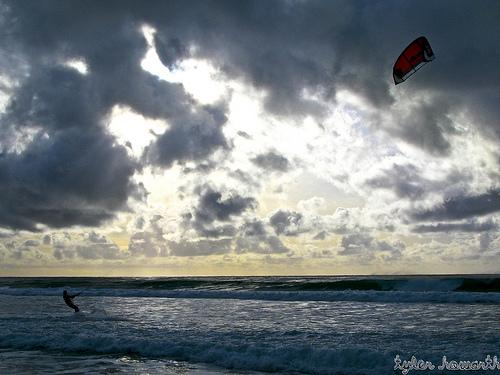Explain what kind of weather is depicted in the image and how it affects the overall atmosphere. The weather in the image showcases an overcast sky with a hidden sun trying to peek through the thickening clouds, lending to an air of intrigue and otherworldly beauty that meshes seamlessly with the calm waters and peaceful beach. How would you describe the water in the image to a person who cannot see the image? The waters in the image are calm and wavey, with various shades of blue, light reflecting from certain points, and the gentle waves rolling towards the shore, creating a serene and inviting scene. Choose three objects from the image and comment about their appearance. The fascinating black clouds contrast beautifully against the white backdrop of the sky, while an orange and red parasail adds a touch of color to the overall scene. The shallowest water nearest the beach showcases a serene atmosphere, inviting one to step in. Create a poetic description of the scene depicted in the image. In a serene landscape where waves gently caress the shore, a daring soul braves the water's embrace, parasailing against a sky where sunlight seeks to pierce the vast gray clouds. What is the most conspicuous aspect of this image, and how does it relate to the location's atmosphere? The sky with its overcast appearance and rays of sunlight striving to break through the clouds is the most conspicuous aspect, which contributes to the captivating and almost ethereal atmosphere of this beach location. If you were to promote a sunscreen brand using this image, what would be the main points to focus on? In this captivating scene where the hidden sun's rays pierce the cloudy sky, gentle waves lap against the shore, and adventurous souls glide above the tranquil waters, our sunscreen allows you to embrace nature's beauty with ultimate protection against the sun's elusive yet powerful embrace. Describe the general mood of the scene in the image. The scene in the image has a tranquil and relaxing mood, with the calm waters, the peaceful beach, and the dramatic sky creating a soothing ambiance, perfect for a retreat from the hustle and bustle of daily life. Describe the relationship between the sky and the sea in this image. In this mesmerizing scene, the vast expanse of the overcast sky mirrors the calm waters of the sea, with rays of sunlight striving to break through the clouds and light reflecting off the water, creating an enchanting harmony between the elements. Based on the image, describe the activities that might be possible at this location. Visitors to this picturesque location can engage in activities such as parasailing, surfing, wading in the shallow water near the beach, sunbathing on the beach, or simply enjoying the serene atmosphere and stunning views. Imagine you were advertising this image for a travel agency. Describe the scene in a way that would make people want to visit this location. Experience the thrill of adventure as you parasail through the skies in idyllic surroundings, where the calm waters meet a horizon adorned with the soft glow of the hidden sun, creating the perfect backdrop for unforgettable memories. 